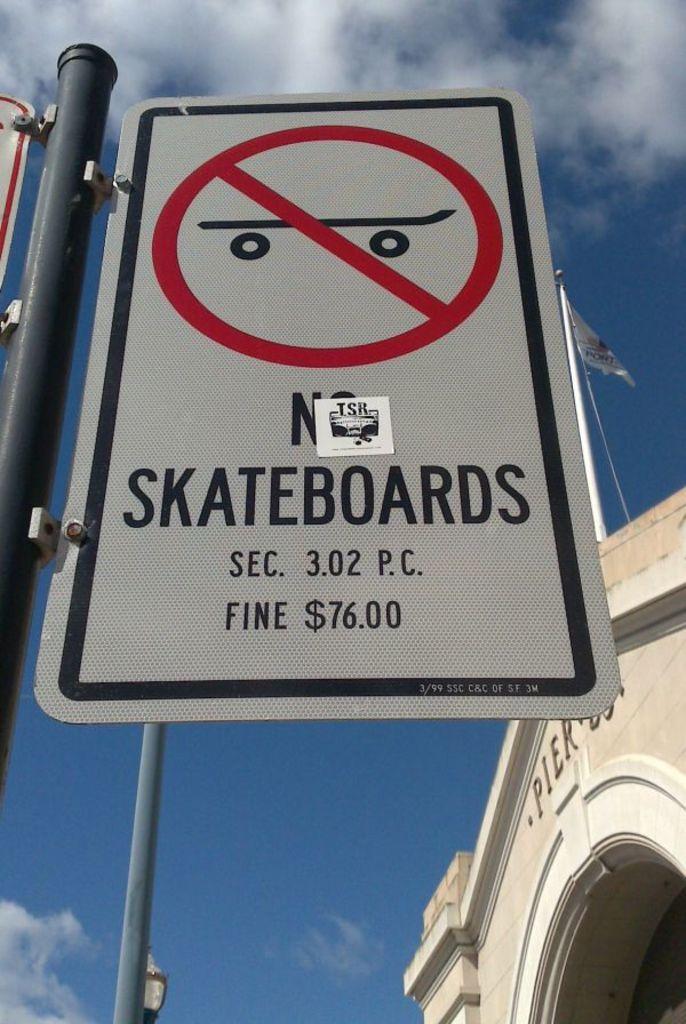What is the fine?
Your answer should be very brief. $76.00. 